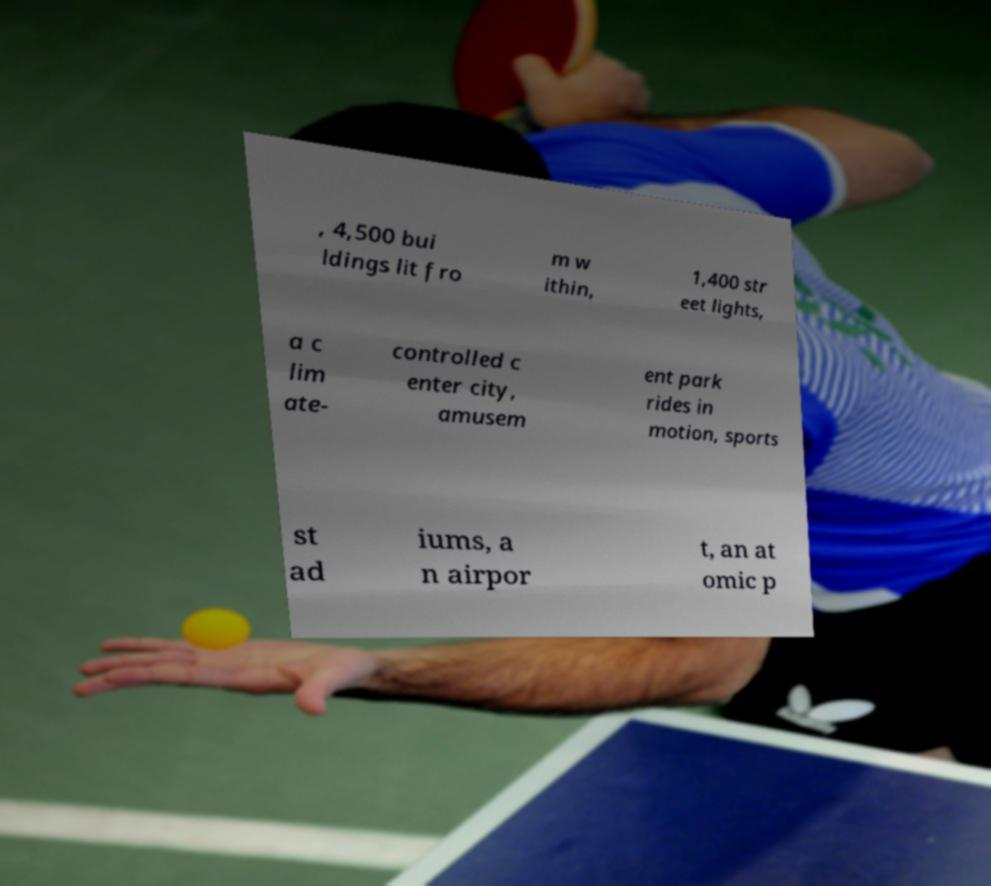What messages or text are displayed in this image? I need them in a readable, typed format. , 4,500 bui ldings lit fro m w ithin, 1,400 str eet lights, a c lim ate- controlled c enter city, amusem ent park rides in motion, sports st ad iums, a n airpor t, an at omic p 